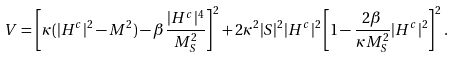Convert formula to latex. <formula><loc_0><loc_0><loc_500><loc_500>V = \left [ \kappa ( | H ^ { c } | ^ { 2 } - M ^ { 2 } ) - \beta \frac { | H ^ { c } | ^ { 4 } } { M _ { S } ^ { 2 } } \right ] ^ { 2 } + 2 \kappa ^ { 2 } | S | ^ { 2 } | H ^ { c } | ^ { 2 } \left [ 1 - \frac { 2 \beta } { \kappa M _ { S } ^ { 2 } } | H ^ { c } | ^ { 2 } \right ] ^ { 2 } .</formula> 